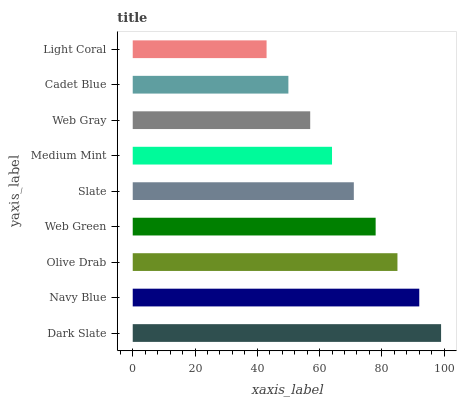Is Light Coral the minimum?
Answer yes or no. Yes. Is Dark Slate the maximum?
Answer yes or no. Yes. Is Navy Blue the minimum?
Answer yes or no. No. Is Navy Blue the maximum?
Answer yes or no. No. Is Dark Slate greater than Navy Blue?
Answer yes or no. Yes. Is Navy Blue less than Dark Slate?
Answer yes or no. Yes. Is Navy Blue greater than Dark Slate?
Answer yes or no. No. Is Dark Slate less than Navy Blue?
Answer yes or no. No. Is Slate the high median?
Answer yes or no. Yes. Is Slate the low median?
Answer yes or no. Yes. Is Web Gray the high median?
Answer yes or no. No. Is Cadet Blue the low median?
Answer yes or no. No. 